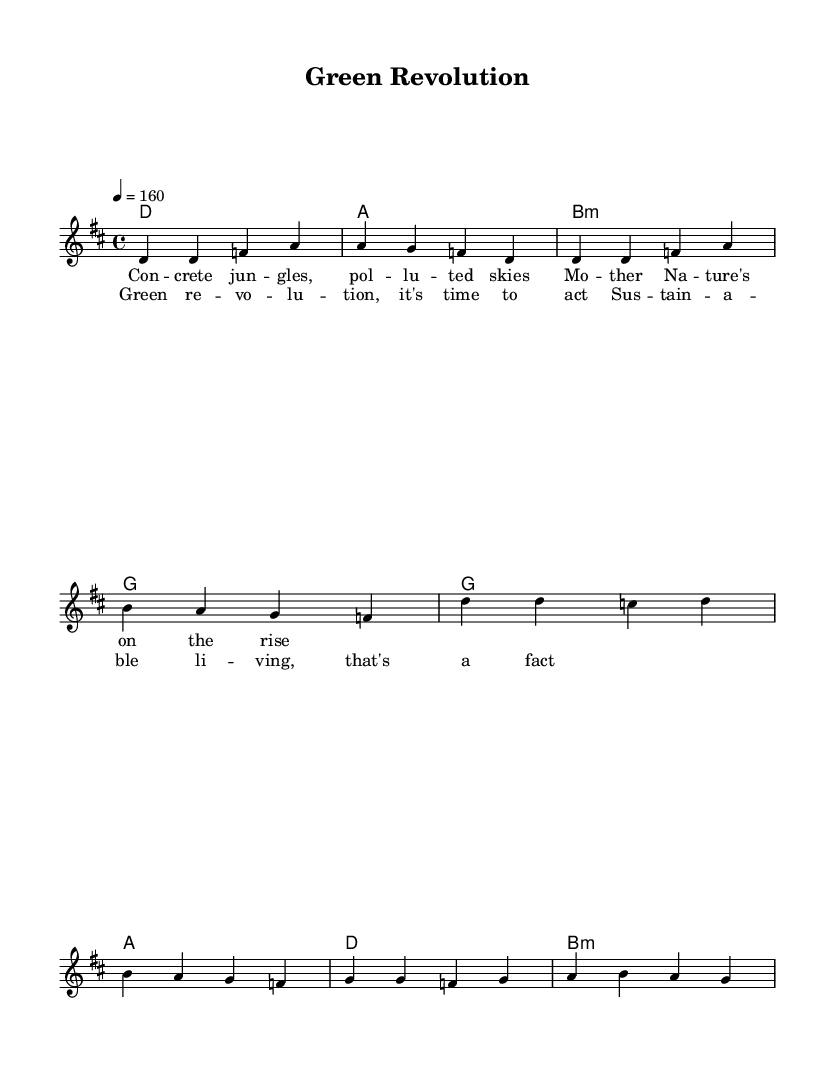What is the key signature of this music? The key signature is indicated by the information at the beginning of the music sheet. In this case, it is specified as D major, which has two sharps (F# and C#).
Answer: D major What is the time signature of this piece? The time signature is shown at the beginning of the sheet music, specifying how many beats are in each measure. Here, it is noted as 4/4, meaning there are four beats per measure and the quarter note gets one beat.
Answer: 4/4 What is the tempo marking for this piece? The tempo marking is indicated in the score and specifies how fast the music should be played. It is set at quarter note equals 160 beats per minute.
Answer: 160 What is the last word of the chorus lyrics? The chorus lyrics are provided in the lyric section of the sheet music and show the text associated with the melody. The last word of the chorus is "fact."
Answer: fact How many measures are in the verse? By counting the measures indicated in the melody and harmonies section, the total number of measures in the verse is four. This includes four distinct groupings of notes or chords.
Answer: 4 What chord is played in the last measure of the chorus? The chord indicated in the last measure is derived from the harmonies section where the chord mode is shown. The last chord in the chorus is B minor.
Answer: B minor What theme is depicted in the lyrics of the song? The lyrics provided in both the verse and chorus reflect a central theme concerning environmental concerns and sustainable living. This is evident from phrases like "Green revolution" and "Sustainable living."
Answer: Eco-punk 